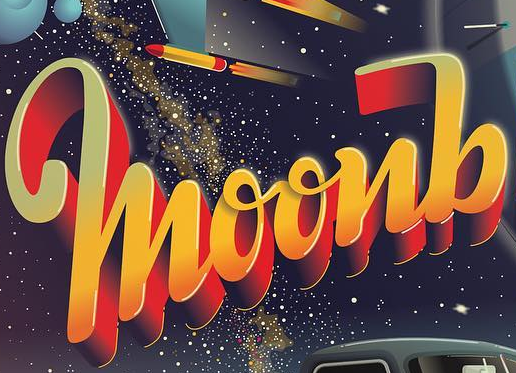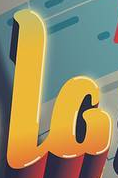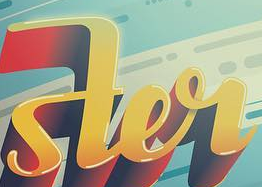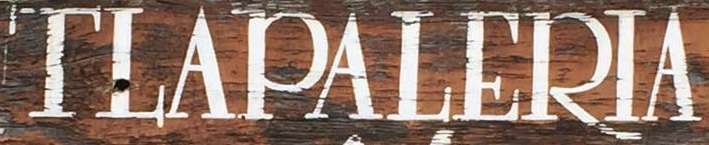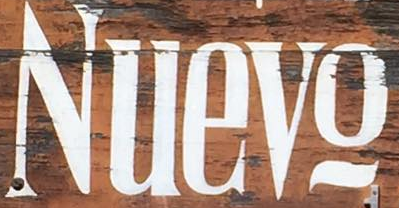What words are shown in these images in order, separated by a semicolon? moonb; la; ster; TLAPALERIA; Nuevo 